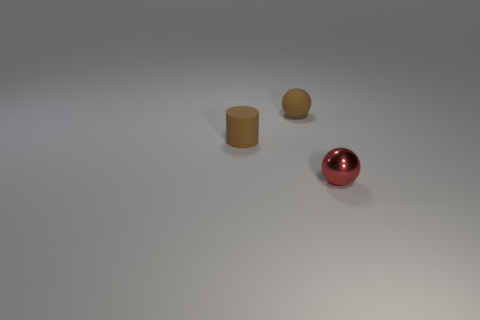How many objects are there in the image, and can you describe them? There are three objects in the image. On the left, there is a beige rubber cylinder standing upright. In the middle, there’s a smaller beige object, which looks like a smaller version of the cylinder. And on the right, there is a shiny, metallic red sphere with a high level of reflectivity. 